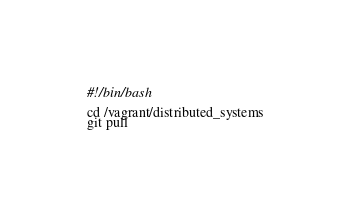<code> <loc_0><loc_0><loc_500><loc_500><_Bash_>#!/bin/bash

cd /vagrant/distributed_systems
git pull
</code> 